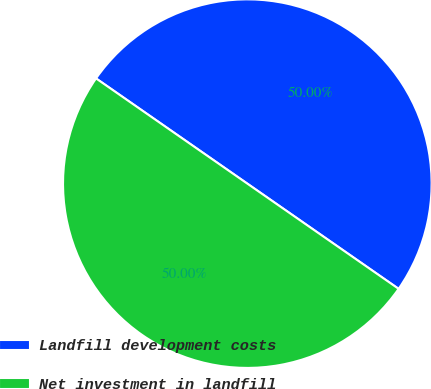Convert chart to OTSL. <chart><loc_0><loc_0><loc_500><loc_500><pie_chart><fcel>Landfill development costs<fcel>Net investment in landfill<nl><fcel>50.0%<fcel>50.0%<nl></chart> 